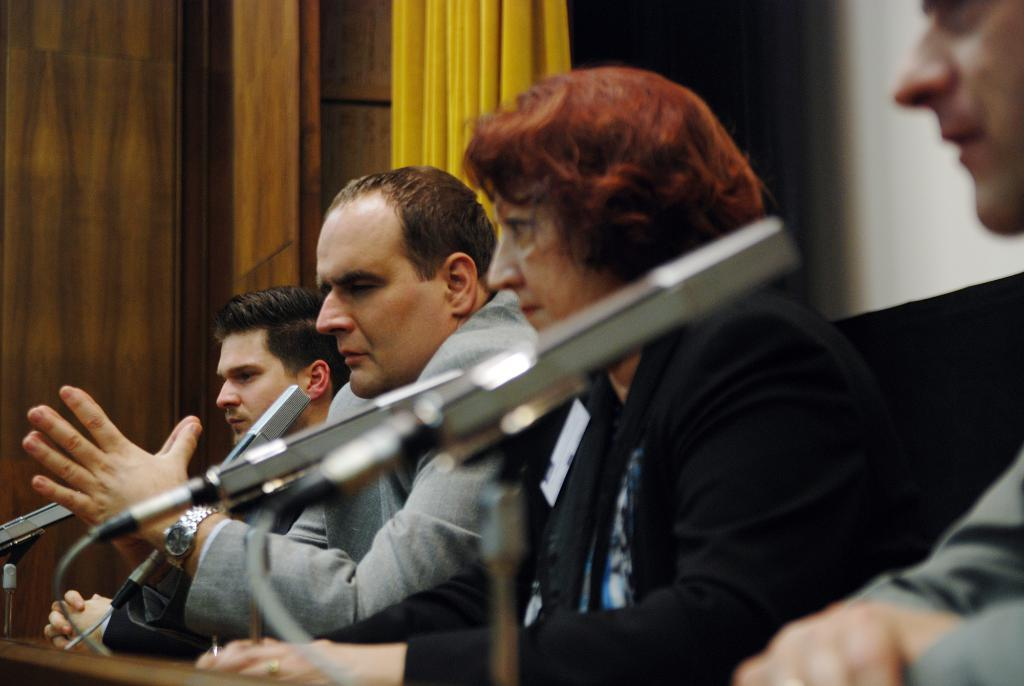What are the people in the image doing? The people in the image are sitting on chairs. What is in front of the chairs? There is a table in front of the chairs. What is on the table? There are microphones on the table. What can be seen in the background of the image? There is a wooden wall and a curtain in the background of the image. What type of hen is sitting on the table in the image? There is no hen present in the image; the table has microphones on it. 